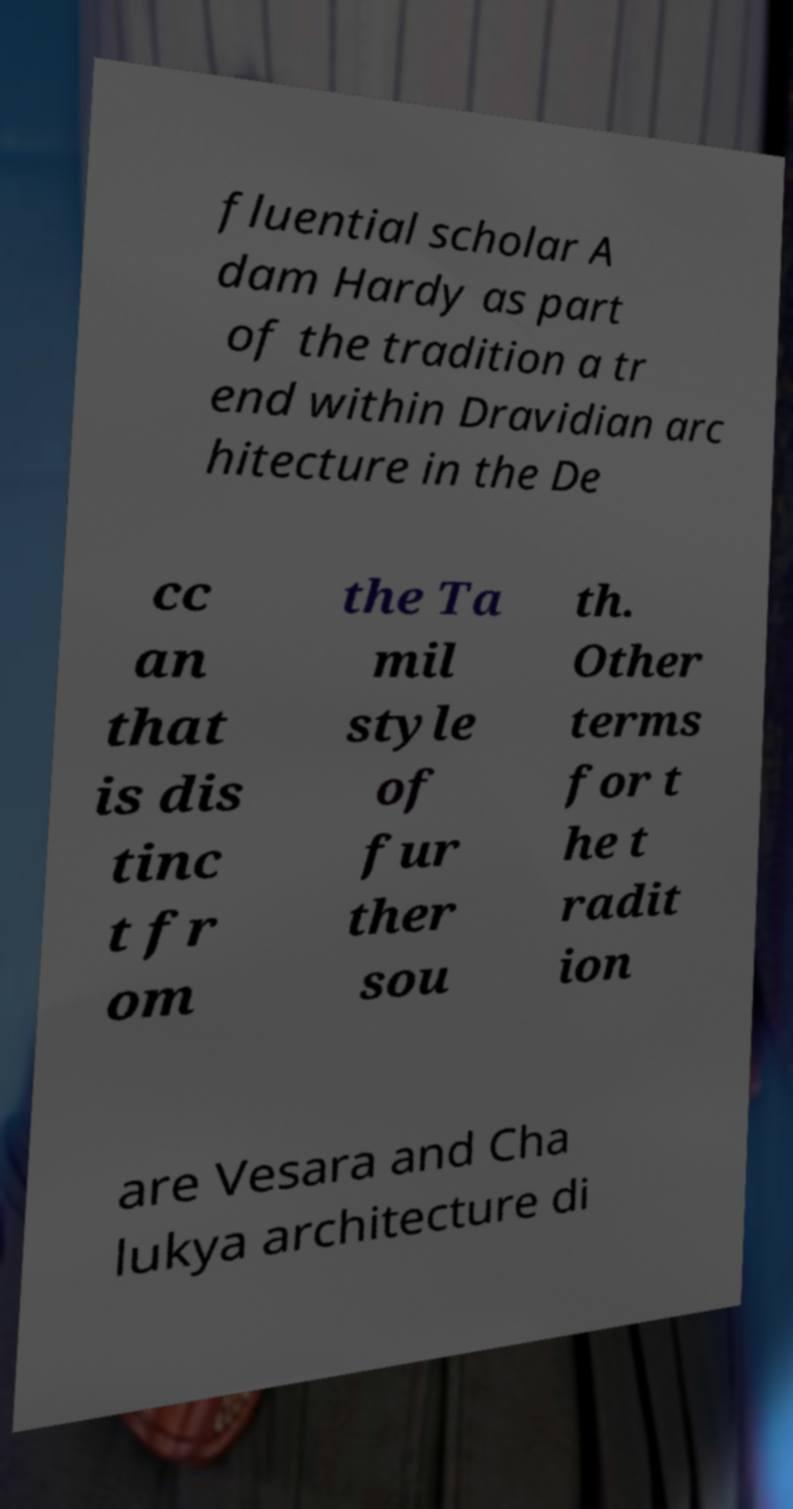Can you accurately transcribe the text from the provided image for me? fluential scholar A dam Hardy as part of the tradition a tr end within Dravidian arc hitecture in the De cc an that is dis tinc t fr om the Ta mil style of fur ther sou th. Other terms for t he t radit ion are Vesara and Cha lukya architecture di 